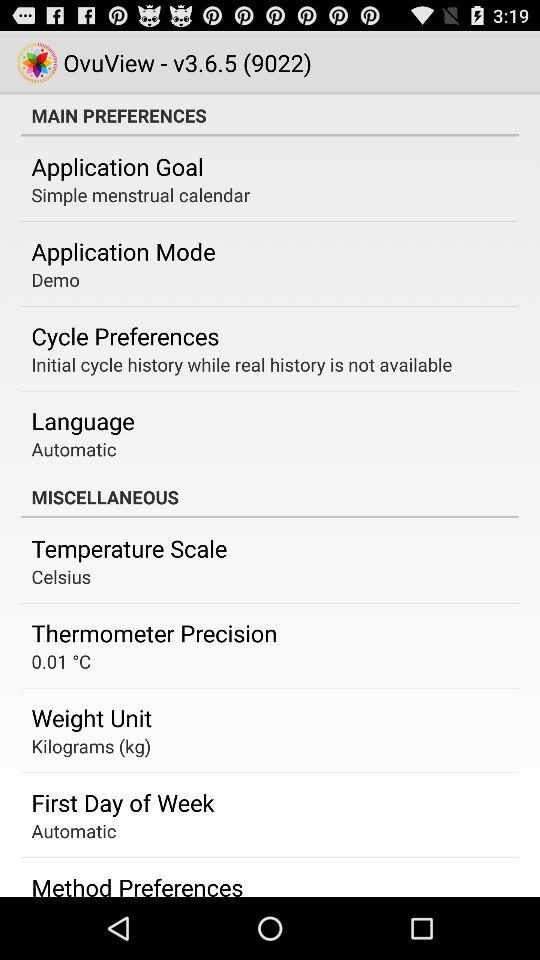What is the goal of the application? The goal of the application is "Simple menstrual calendar". 